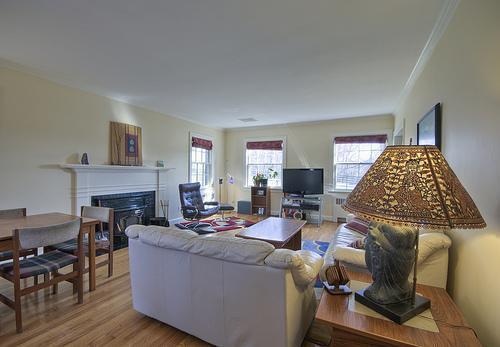How many dinosaurs are in the picture?
Give a very brief answer. 0. How many people are riding on elephants?
Give a very brief answer. 0. 